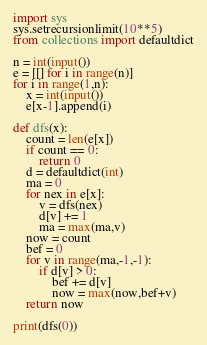Convert code to text. <code><loc_0><loc_0><loc_500><loc_500><_Python_>import sys
sys.setrecursionlimit(10**5)
from collections import defaultdict

n = int(input())
e = [[] for i in range(n)]
for i in range(1,n):
    x = int(input())
    e[x-1].append(i)

def dfs(x):
    count = len(e[x])
    if count == 0:
        return 0
    d = defaultdict(int)
    ma = 0
    for nex in e[x]:
        v = dfs(nex)
        d[v] += 1
        ma = max(ma,v)
    now = count
    bef = 0
    for v in range(ma,-1,-1):
        if d[v] > 0:
            bef += d[v]
            now = max(now,bef+v)
    return now

print(dfs(0))</code> 